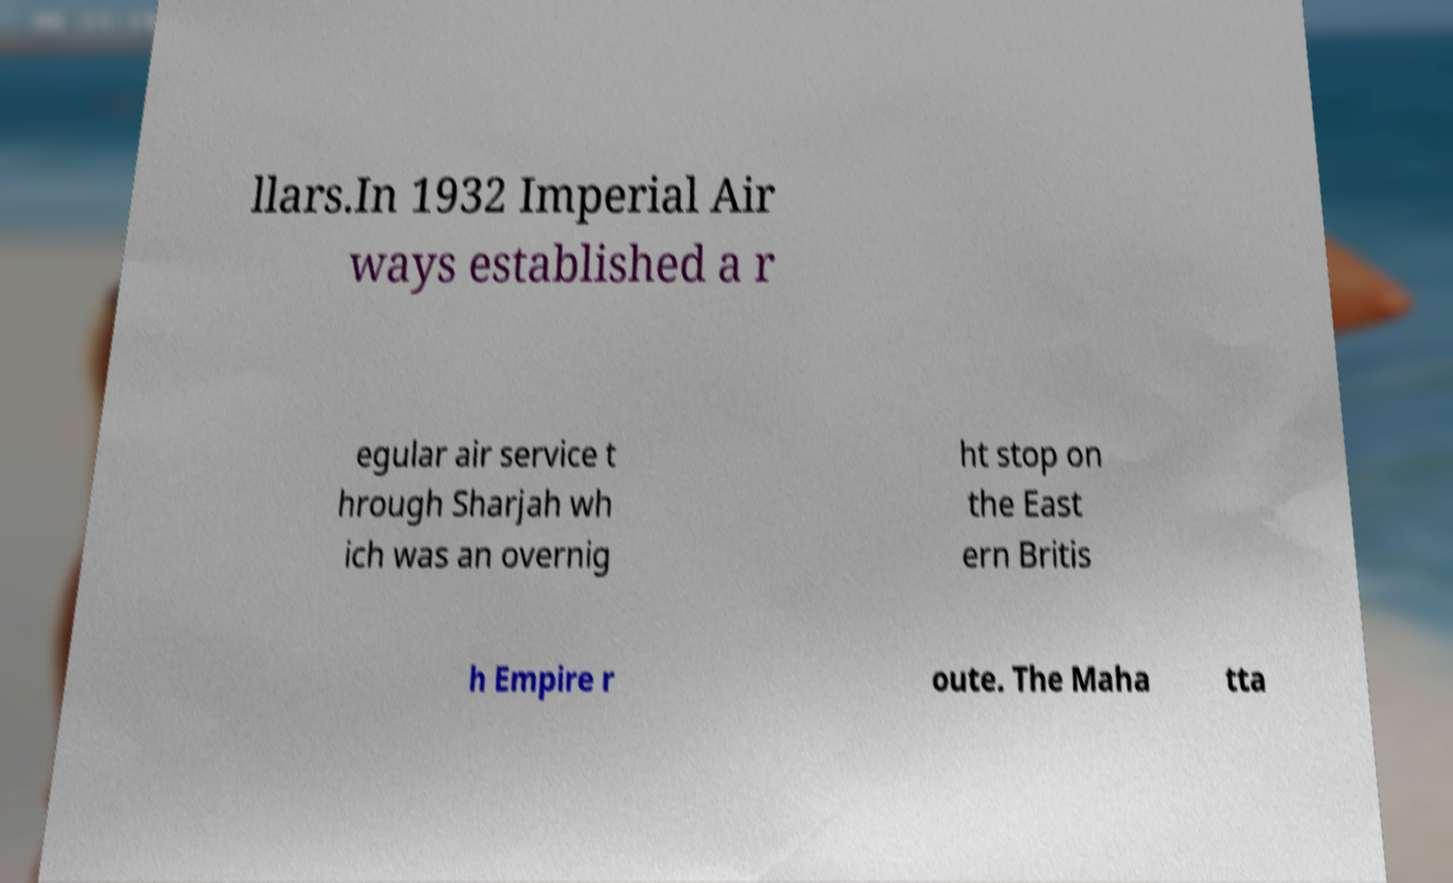There's text embedded in this image that I need extracted. Can you transcribe it verbatim? llars.In 1932 Imperial Air ways established a r egular air service t hrough Sharjah wh ich was an overnig ht stop on the East ern Britis h Empire r oute. The Maha tta 